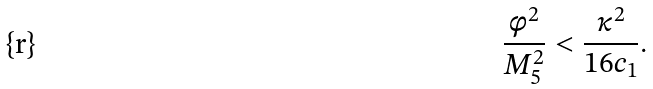<formula> <loc_0><loc_0><loc_500><loc_500>\frac { \phi ^ { 2 } } { M _ { 5 } ^ { 2 } } < \frac { \kappa ^ { 2 } } { 1 6 c _ { 1 } } .</formula> 